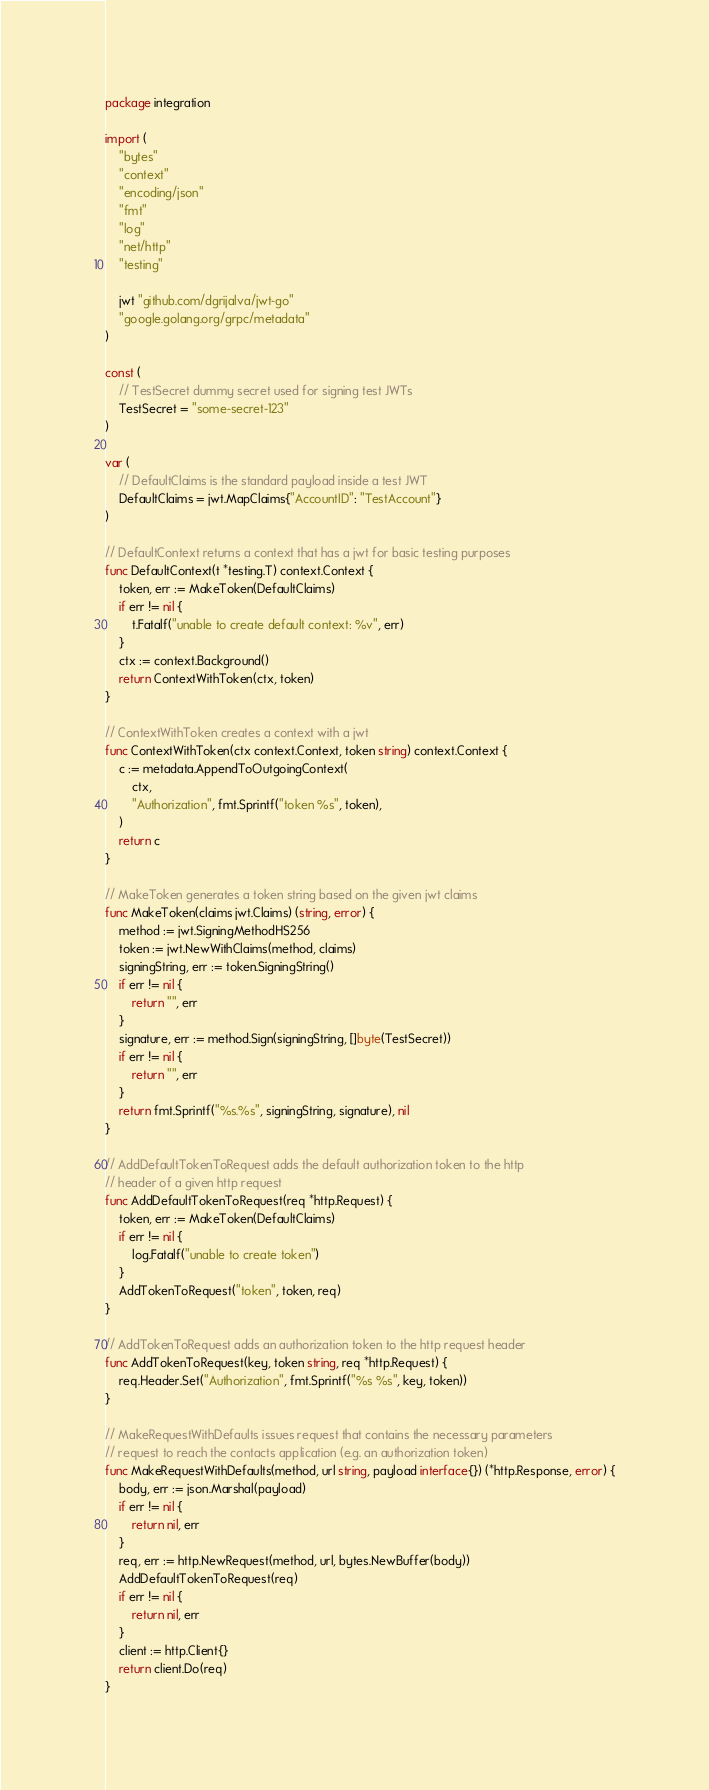<code> <loc_0><loc_0><loc_500><loc_500><_Go_>package integration

import (
	"bytes"
	"context"
	"encoding/json"
	"fmt"
	"log"
	"net/http"
	"testing"

	jwt "github.com/dgrijalva/jwt-go"
	"google.golang.org/grpc/metadata"
)

const (
	// TestSecret dummy secret used for signing test JWTs
	TestSecret = "some-secret-123"
)

var (
	// DefaultClaims is the standard payload inside a test JWT
	DefaultClaims = jwt.MapClaims{"AccountID": "TestAccount"}
)

// DefaultContext returns a context that has a jwt for basic testing purposes
func DefaultContext(t *testing.T) context.Context {
	token, err := MakeToken(DefaultClaims)
	if err != nil {
		t.Fatalf("unable to create default context: %v", err)
	}
	ctx := context.Background()
	return ContextWithToken(ctx, token)
}

// ContextWithToken creates a context with a jwt
func ContextWithToken(ctx context.Context, token string) context.Context {
	c := metadata.AppendToOutgoingContext(
		ctx,
		"Authorization", fmt.Sprintf("token %s", token),
	)
	return c
}

// MakeToken generates a token string based on the given jwt claims
func MakeToken(claims jwt.Claims) (string, error) {
	method := jwt.SigningMethodHS256
	token := jwt.NewWithClaims(method, claims)
	signingString, err := token.SigningString()
	if err != nil {
		return "", err
	}
	signature, err := method.Sign(signingString, []byte(TestSecret))
	if err != nil {
		return "", err
	}
	return fmt.Sprintf("%s.%s", signingString, signature), nil
}

// AddDefaultTokenToRequest adds the default authorization token to the http
// header of a given http request
func AddDefaultTokenToRequest(req *http.Request) {
	token, err := MakeToken(DefaultClaims)
	if err != nil {
		log.Fatalf("unable to create token")
	}
	AddTokenToRequest("token", token, req)
}

// AddTokenToRequest adds an authorization token to the http request header
func AddTokenToRequest(key, token string, req *http.Request) {
	req.Header.Set("Authorization", fmt.Sprintf("%s %s", key, token))
}

// MakeRequestWithDefaults issues request that contains the necessary parameters
// request to reach the contacts application (e.g. an authorization token)
func MakeRequestWithDefaults(method, url string, payload interface{}) (*http.Response, error) {
	body, err := json.Marshal(payload)
	if err != nil {
		return nil, err
	}
	req, err := http.NewRequest(method, url, bytes.NewBuffer(body))
	AddDefaultTokenToRequest(req)
	if err != nil {
		return nil, err
	}
	client := http.Client{}
	return client.Do(req)
}
</code> 